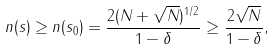Convert formula to latex. <formula><loc_0><loc_0><loc_500><loc_500>n ( s ) \geq n ( s _ { 0 } ) = \frac { 2 ( N + \sqrt { N } ) ^ { 1 / 2 } } { 1 - \delta } \geq \frac { 2 \sqrt { N } } { 1 - \delta } ,</formula> 